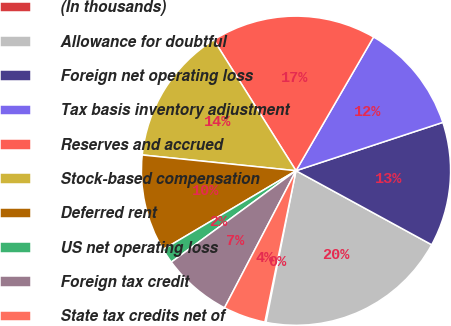Convert chart to OTSL. <chart><loc_0><loc_0><loc_500><loc_500><pie_chart><fcel>(In thousands)<fcel>Allowance for doubtful<fcel>Foreign net operating loss<fcel>Tax basis inventory adjustment<fcel>Reserves and accrued<fcel>Stock-based compensation<fcel>Deferred rent<fcel>US net operating loss<fcel>Foreign tax credit<fcel>State tax credits net of<nl><fcel>0.12%<fcel>20.16%<fcel>13.01%<fcel>11.57%<fcel>17.3%<fcel>14.44%<fcel>10.14%<fcel>1.55%<fcel>7.28%<fcel>4.42%<nl></chart> 